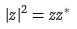<formula> <loc_0><loc_0><loc_500><loc_500>| z | ^ { 2 } = z z ^ { * }</formula> 